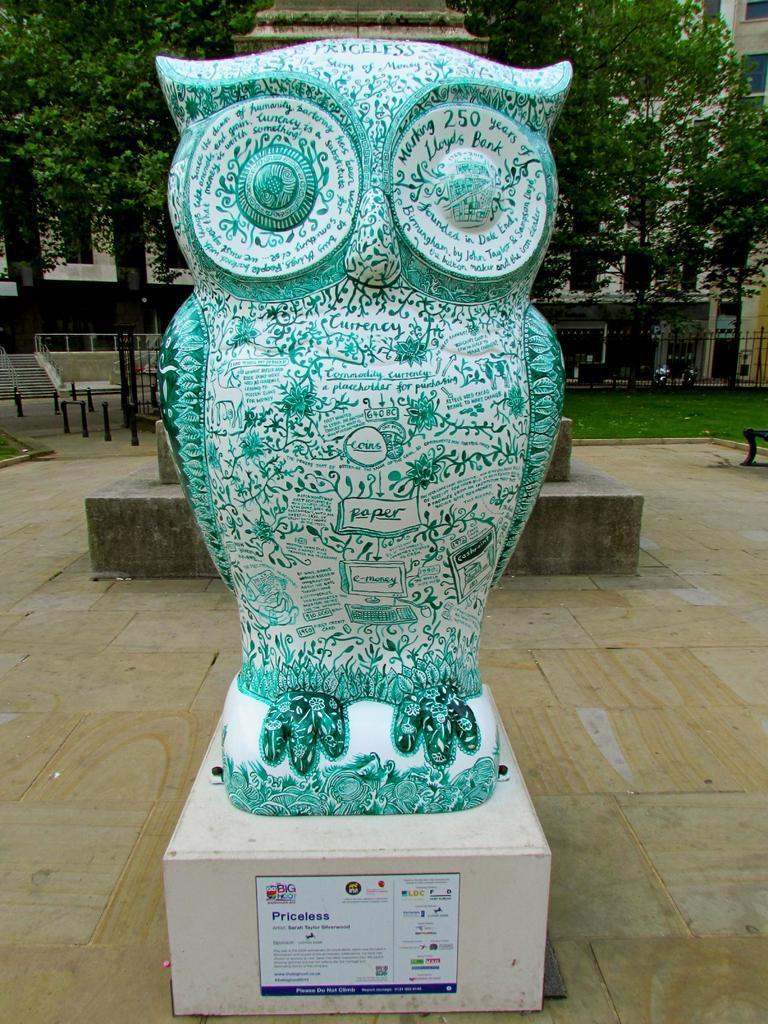Please provide a concise description of this image. Here we can see a statue of an owl. Here there is a platform. Background we can see trees, buildings, windows, rods, fencing, poles, stairs and grass. 